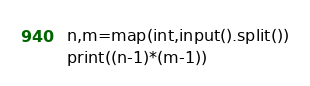<code> <loc_0><loc_0><loc_500><loc_500><_Python_>n,m=map(int,input().split())
print((n-1)*(m-1))</code> 